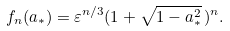Convert formula to latex. <formula><loc_0><loc_0><loc_500><loc_500>f _ { n } ( a _ { * } ) = \varepsilon ^ { n / 3 } ( 1 + \sqrt { 1 - a ^ { 2 } _ { * } } \, ) ^ { n } .</formula> 